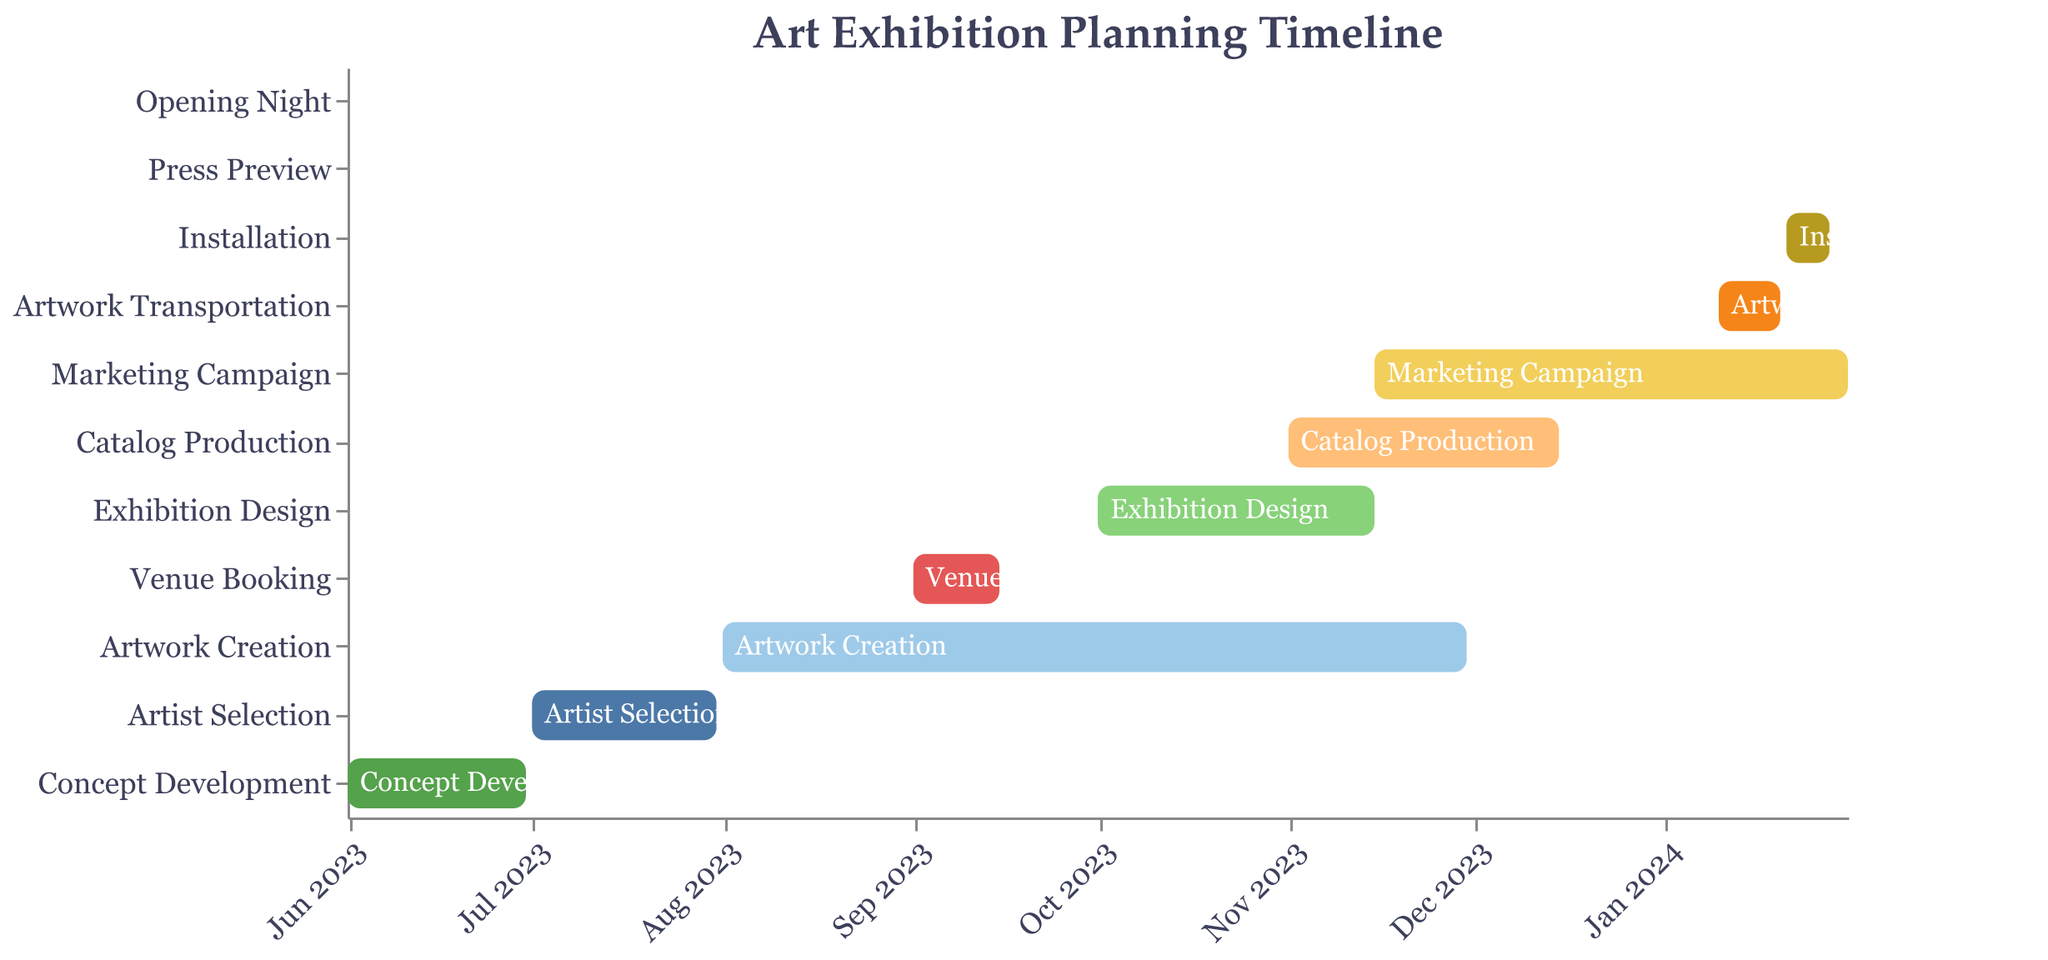When does the "Artist Selection" stage start and end? According to the figure, the "Artist Selection" stage starts on July 1, 2023, and ends on July 31, 2023.
Answer: July 1, 2023, to July 31, 2023 What is the duration of the "Marketing Campaign" stage? To find the duration, subtract the start date from the end date: from November 15, 2023, to January 31, 2024. That's 2 months and 16 days.
Answer: 2 months, 16 days Which stage lasts the longest? Look at the lengths of the bars in the Gantt chart. The "Artwork Creation" bar is the longest, spanning from August 1, 2023, to November 30, 2023, making it 4 months long.
Answer: Artwork Creation Do any two stages overlap, and if so, which ones? Check for bars that visually overlap in the timeline. "Artwork Creation" and "Venue Booking" overlap in September 2023, and "Catalog Production" and "Marketing Campaign" overlap from November 15, 2023, to December 15, 2023.
Answer: Artwork Creation & Venue Booking, Catalog Production & Marketing Campaign What stages occur in January 2024? Check for bars spanning January 2024. The stages are "Marketing Campaign," "Artwork Transportation," "Installation," "Press Preview," and "Opening Night."
Answer: Marketing Campaign, Artwork Transportation, Installation, Press Preview, Opening Night When does the "Installation" stage occur? The "Installation" stage begins on January 21, 2024, and ends on January 28, 2024.
Answer: January 21, 2024 - January 28, 2024 Which stage immediately follows "Installation"? The stage that starts immediately after "Installation" is "Press Preview," which occurs on January 29, 2024.
Answer: Press Preview How many stages span two months or more? Count the bars that are 2 months or longer: "Artwork Creation," "Marketing Campaign." That's 2 stages.
Answer: 2 stages 